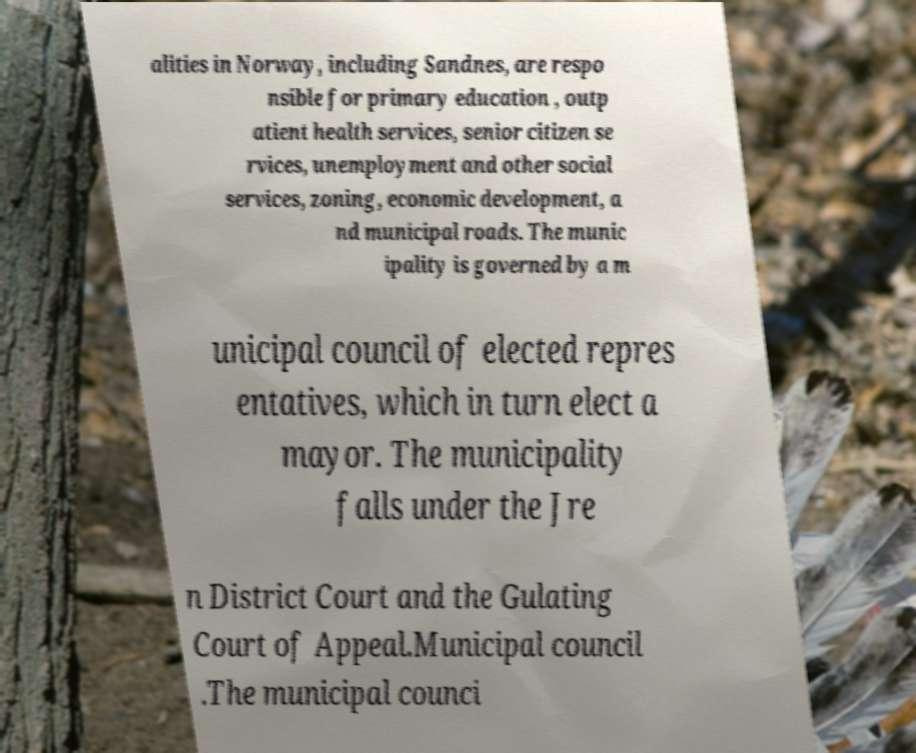Can you read and provide the text displayed in the image?This photo seems to have some interesting text. Can you extract and type it out for me? alities in Norway, including Sandnes, are respo nsible for primary education , outp atient health services, senior citizen se rvices, unemployment and other social services, zoning, economic development, a nd municipal roads. The munic ipality is governed by a m unicipal council of elected repres entatives, which in turn elect a mayor. The municipality falls under the Jre n District Court and the Gulating Court of Appeal.Municipal council .The municipal counci 